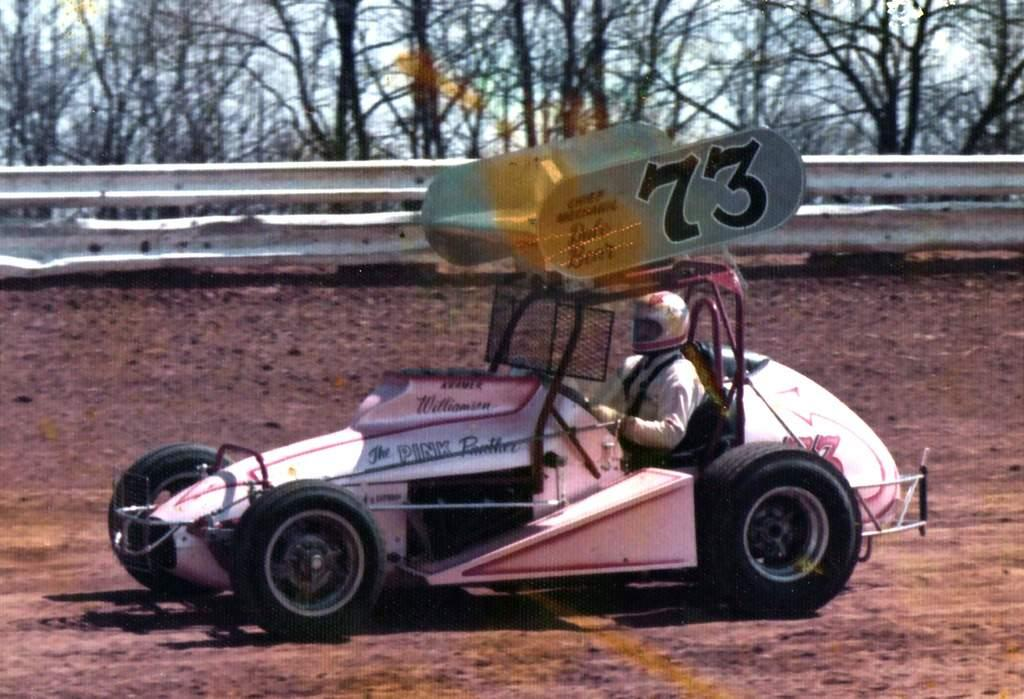Provide a one-sentence caption for the provided image. A small race car that looks hand-built has the number 73 and sits on a dirt track. 